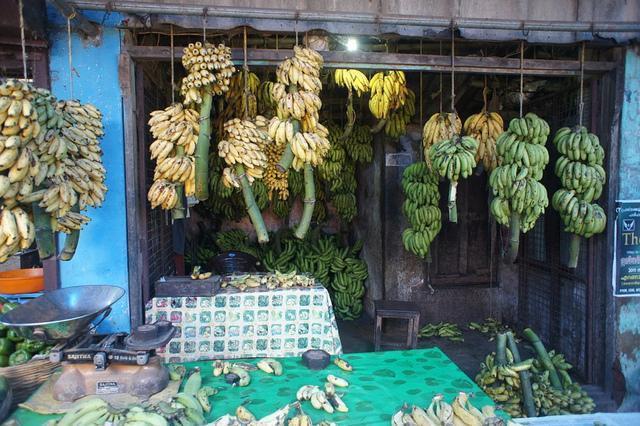How many tables?
Give a very brief answer. 2. How many dining tables are there?
Give a very brief answer. 2. How many bananas are there?
Give a very brief answer. 5. 